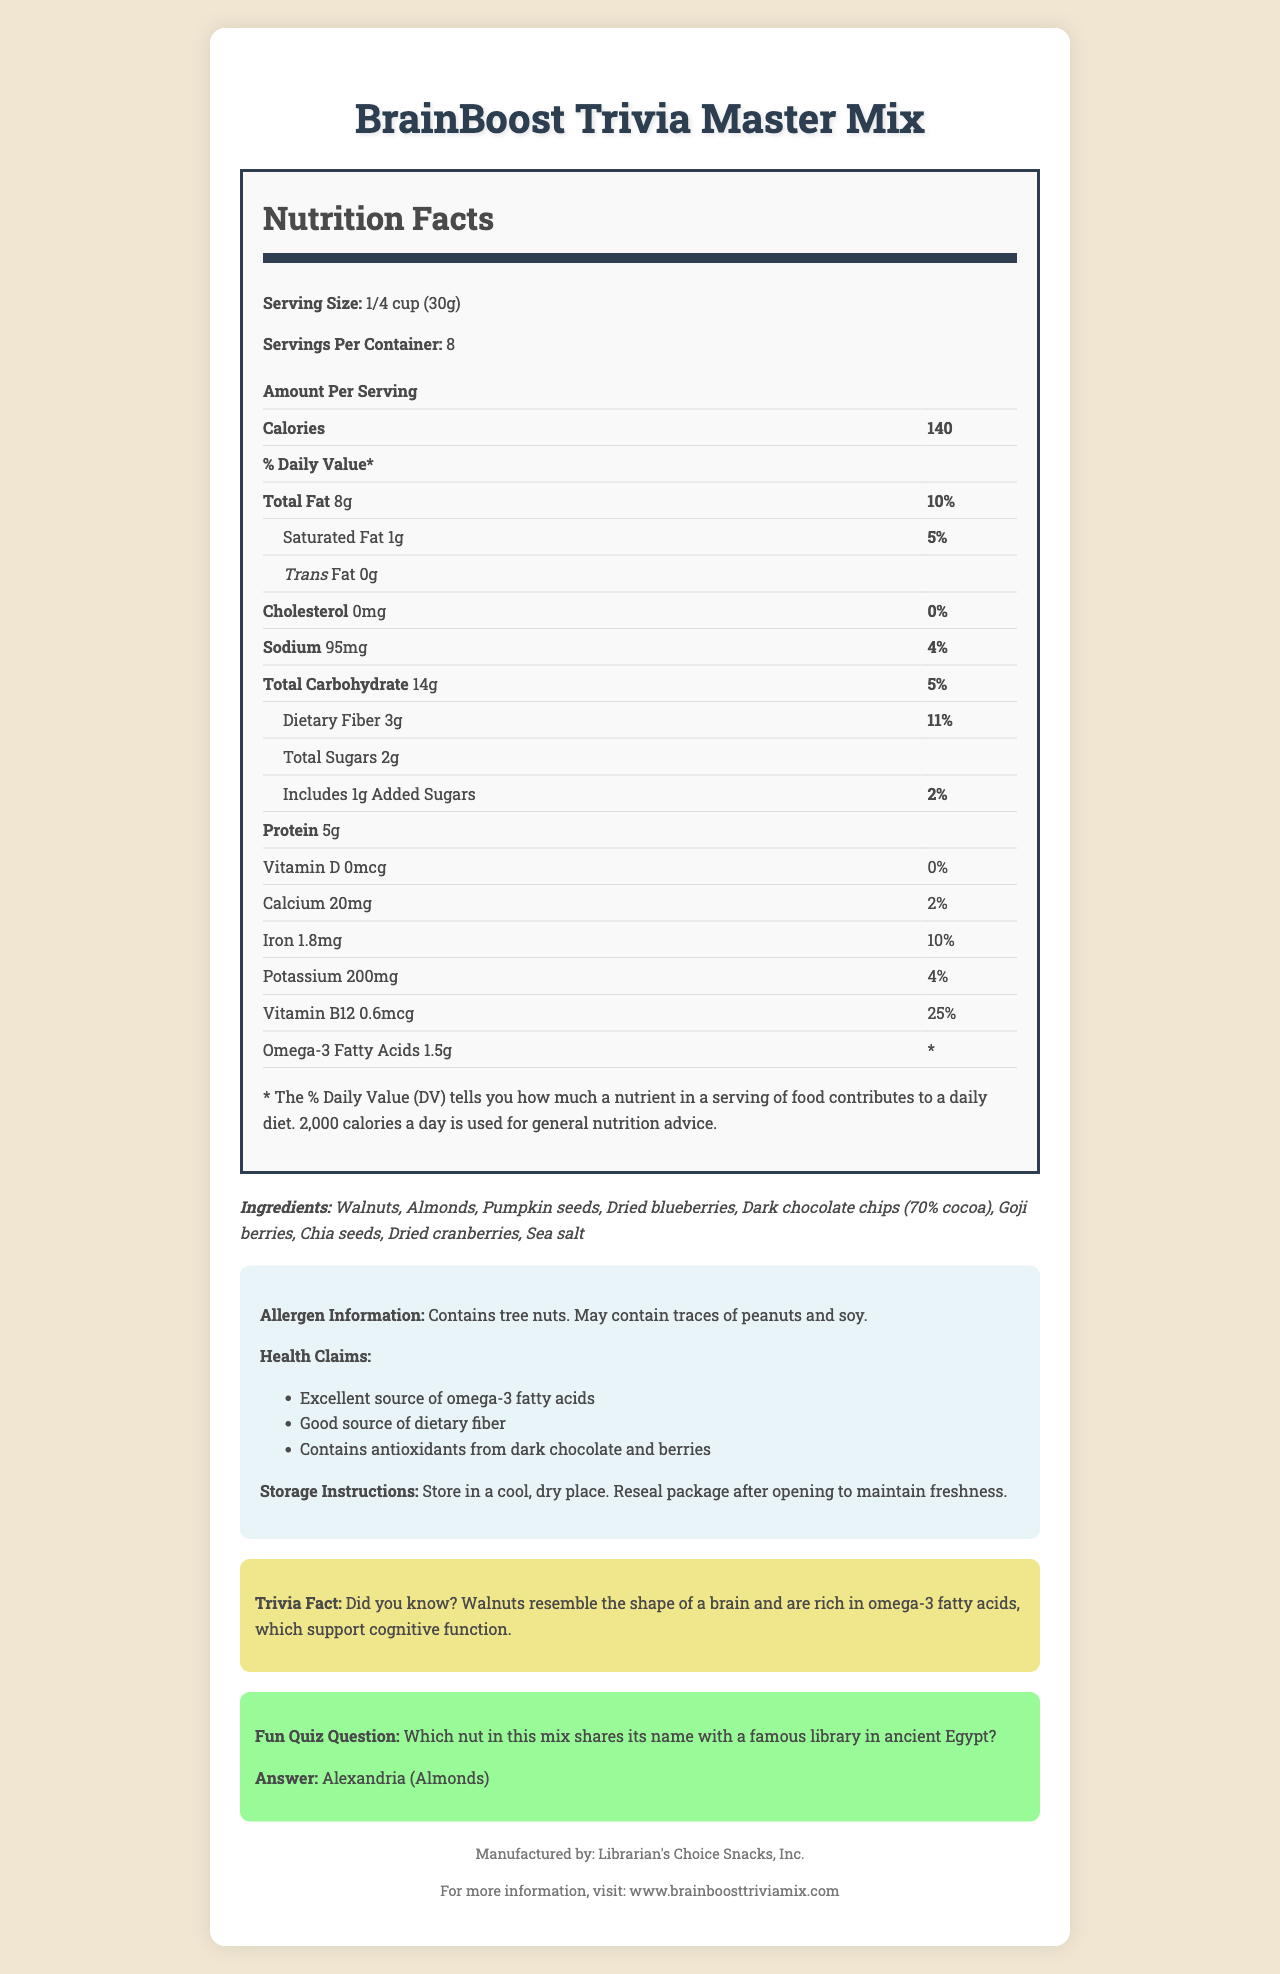what is the serving size? The serving size is mentioned in the "Nutrition Facts" section under "Serving Size."
Answer: 1/4 cup (30g) how many calories are in a serving? The calorie count per serving is listed in the "Nutrition Facts" section under "Calories."
Answer: 140 calories what is the total fat content per serving? The total fat content is listed in the "Nutrition Facts" section under "Total Fat."
Answer: 8g how much dietary fiber does a serving contain? The dietary fiber content per serving is specified in the "Nutrition Facts" section under "Dietary Fiber."
Answer: 3g what percentage of the daily value of iron is provided by one serving? The percentage of the daily value for iron is listed in the "Nutrition Facts" section under "Iron."
Answer: 10% which ingredient is not found in the BrainBoost Trivia Master Mix? A. Walnuts B. Almonds C. Peanuts D. Pumpkin seeds The ingredients are listed under "Ingredients," and peanuts are not mentioned, although it states it "May contain traces of peanuts."
Answer: C how much protein is there in one serving of the mix? The protein content per serving is mentioned in the "Nutrition Facts" section under "Protein."
Answer: 5g True or False: The BrainBoost Trivia Master Mix contains trans fat. The "Nutrition Facts" section specifically states "Trans Fat 0g."
Answer: False which nutrient is provided in the greatest amount as a percentage of the daily value? A. Vitamin D B. Calcium C. Vitamin B12 D. Potassium Vitamin B12 provides 25% of the daily value, which is the highest percentage among the nutrients listed.
Answer: C what is the fun quiz question related to the nuts in the mix? The fun quiz question is displayed prominently under the "Fun Quiz Question" section.
Answer: Which nut in this mix shares its name with a famous library in ancient Egypt? does the product contain any allergens? The "Allergen Information" section states that the product contains tree nuts and may contain traces of peanuts and soy.
Answer: Yes summarize the main idea of this document. The document contains various sections including nutrition facts, ingredients, allergen information, health claims, and trivia, giving a comprehensive overview of the product.
Answer: The document provides detailed nutritional information and ingredients for the BrainBoost Trivia Master Mix, emphasizing its health benefits such as being a good source of omega-3 fatty acids and dietary fiber. It also includes fun trivia and quiz questions related to the product. what is the storage instruction for the BrainBoost Trivia Master Mix? The storage instructions are mentioned in the "Storage Instructions" section.
Answer: Store in a cool, dry place. Reseal package after opening to maintain freshness. name one of the health claims made about the BrainBoost Trivia Master Mix. The health claims are listed in the "Health Claims" section, one of which is that the product is an excellent source of omega-3 fatty acids.
Answer: Excellent source of omega-3 fatty acids what is the total carbohydrate content per serving, including the percentage of daily value? The total carbohydrate content and its daily value percentage are listed in the "Nutrition Facts" section under "Total Carbohydrate."
Answer: 14g, 5% which company manufactures the BrainBoost Trivia Master Mix? The manufacturer's name is listed under the "Manufactured by" section at the bottom of the document.
Answer: Librarian's Choice Snacks, Inc. does one serving of this mix provide any vitamin D? The "Nutrition Facts" section shows that Vitamin D is 0mcg with 0% daily value.
Answer: No what is the protein content of the BrainBoost Trivia Master Mix? A. 3g B. 4g C. 5g D. 6g The protein content, listed in the "Nutrition Facts" section, is 5g.
Answer: C what unique fact is shared in the trivia section? The trivia fact is displayed in the "Trivia Fact" section.
Answer: Walnuts resemble the shape of a brain and are rich in omega-3 fatty acids, which support cognitive function. which percent daily value does one serving provide for cholesterol? The "Nutrition Facts" section shows that cholesterol is 0mg with 0% daily value.
Answer: 0% which tree nut is not present in this mix? The "Ingredients" section lists walnuts and almonds but not pecans.
Answer: Pecans 